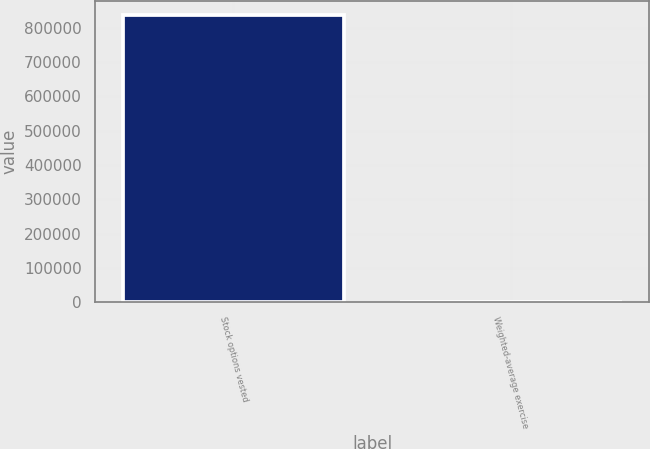Convert chart. <chart><loc_0><loc_0><loc_500><loc_500><bar_chart><fcel>Stock options vested<fcel>Weighted-average exercise<nl><fcel>835982<fcel>47.21<nl></chart> 